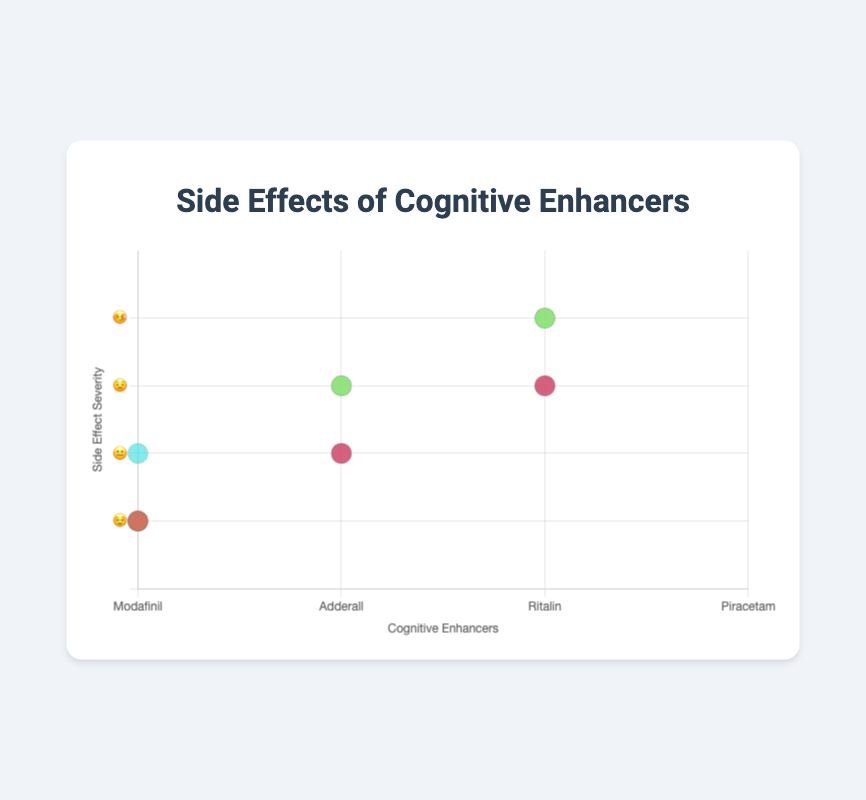Which cognitive enhancer has the most severe side effect? By analyzing the y-axis (severity) values for each drug, we can see that Adderall and Ritalin both have side effects at the "🤒" severity level. Of the side effects listed, "Loss of appetite" for Adderall and "Mood swings" for Ritalin are mapped to the highest possible severity level. However, they both share the same severity, so both answers are correct.
Answer: Adderall and Ritalin What is the least severe side effect of Modafinil? Checking the y-axis (severity) values for the side effects of Modafinil, the lowest severity is "😌" which corresponds to "Headache".
Answer: Headache Which drug has side effects with the severity of "😟"? We look at the y-axis values corresponding to "😟" level. We find that Modafinil (Anxiety), Adderall (Insomnia), Ritalin (Increased heart rate), and Piracetam (Fatigue) each has a side effect at this severity level.
Answer: Modafinil, Adderall, Ritalin, and Piracetam How many side effects are categorized under "😐"? Checking all the drugs, Modafinil (Nausea), Ritalin (Nervousness), and Piracetam (Gastrointestinal issues) each have a side effect at "😐". By counting these records, we find there are 3 under this category.
Answer: 3 Which cognitive enhancer has the most side effects listed on the chart? Looking at the number of side effects represented for each drug:
- Modafinil: 3
- Adderall: 3
- Ritalin: 3
- Piracetam: 3
Each drug has 3 side effects listed, so they all have an equal number.
Answer: Modafinil, Adderall, Ritalin, and Piracetam each have 3 Compare the side effects of Ritalin and Adderall; which one has a more severe side effect profile? By comparing the severity levels for each: 
- Ritalin has side effects at 😐, 😟, and 🤒
- Adderall has side effects at 😌, 😟, and 🤒
Since Adderall includes a side effect at the lowest severity level (😌) compared to Ritalin’s lowest being 😐, Ritalin has a more severe side effect profile overall.
Answer: Ritalin How does Piracetam’s side effect severity distribution compare with Modafinil’s? - Modafinil's side effects: 😌 (Headache), 😐 (Nausea), 😟 (Anxiety)
- Piracetam's side effects: 😌 (Dizziness), 😐 (Gastrointestinal issues), 😟 (Fatigue)
Both drugs share similar severity levels for their respective side effects, distributed one each at 😌, 😐, and 😟.
Answer: Similar, 1 each at 😌, 😐, and 😟 